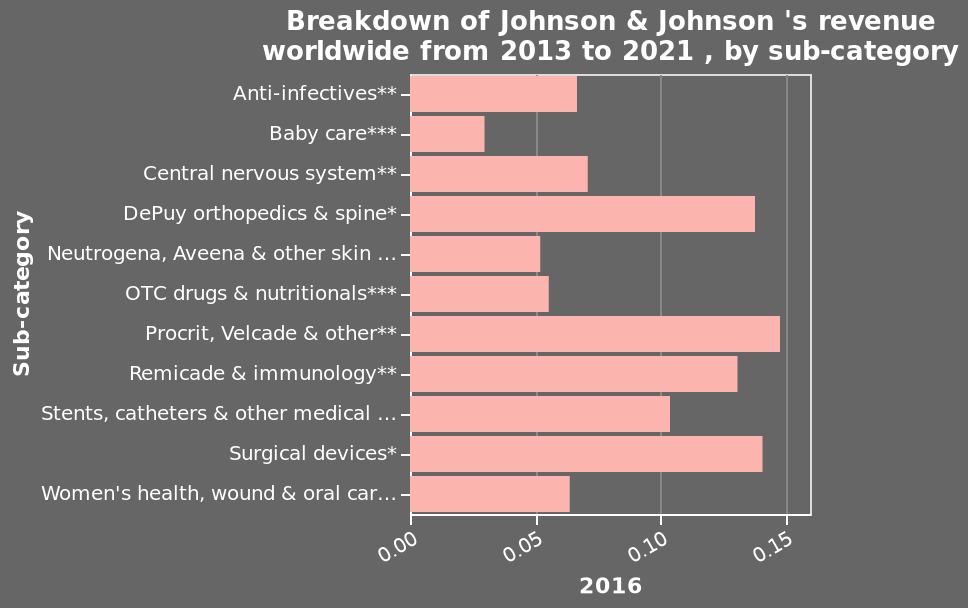<image>
Offer a thorough analysis of the image. Baby care generates the lowest income. Procrit and Velcade generate the highest income. What is the income generated by the baby care category?  The income generated by the baby care category is the lowest. What is the specific year marked on the x-axis of the bar diagram?  The specific year marked on the x-axis of the bar diagram is 2016. Which two products generate the highest income?  Procrit and Velcade generate the highest income. 